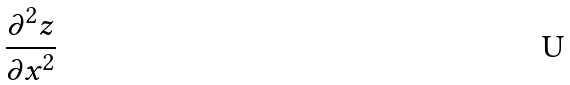Convert formula to latex. <formula><loc_0><loc_0><loc_500><loc_500>\frac { \partial ^ { 2 } z } { \partial x ^ { 2 } }</formula> 